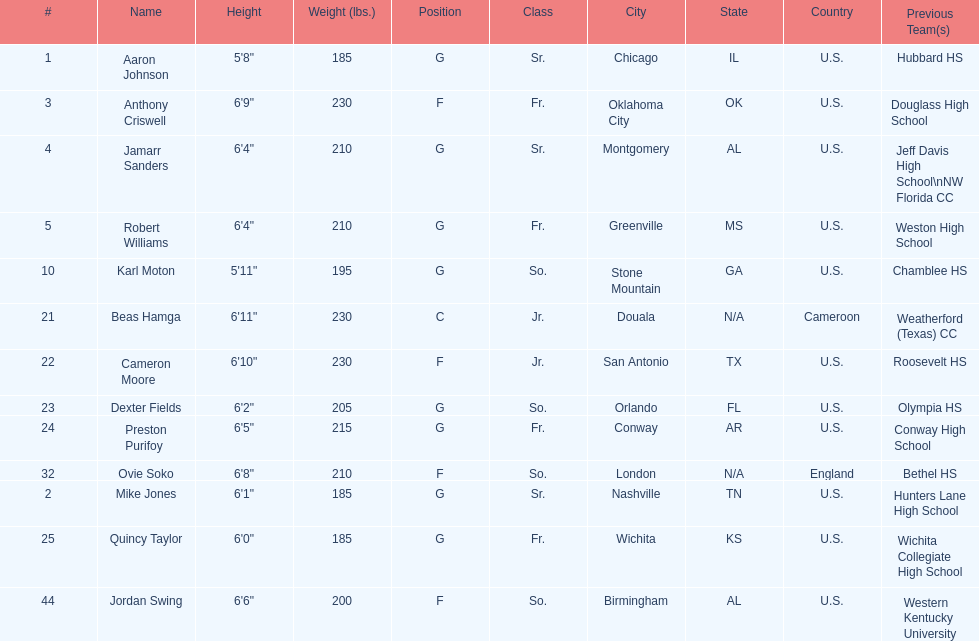Who is first on the roster? Aaron Johnson. 